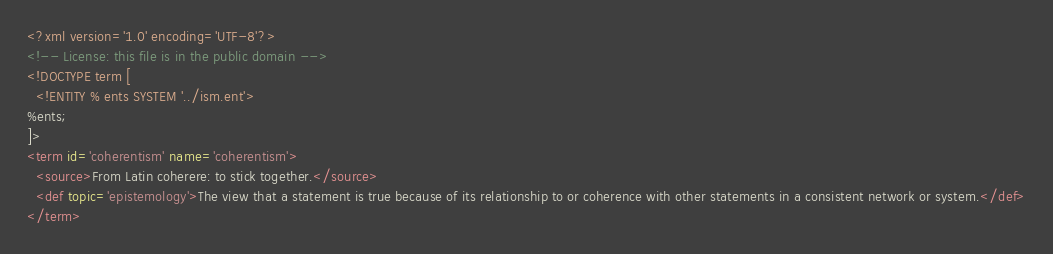Convert code to text. <code><loc_0><loc_0><loc_500><loc_500><_XML_><?xml version='1.0' encoding='UTF-8'?>
<!-- License: this file is in the public domain -->
<!DOCTYPE term [
  <!ENTITY % ents SYSTEM '../ism.ent'>
%ents;
]>
<term id='coherentism' name='coherentism'>
  <source>From Latin coherere: to stick together.</source>
  <def topic='epistemology'>The view that a statement is true because of its relationship to or coherence with other statements in a consistent network or system.</def>
</term>
</code> 